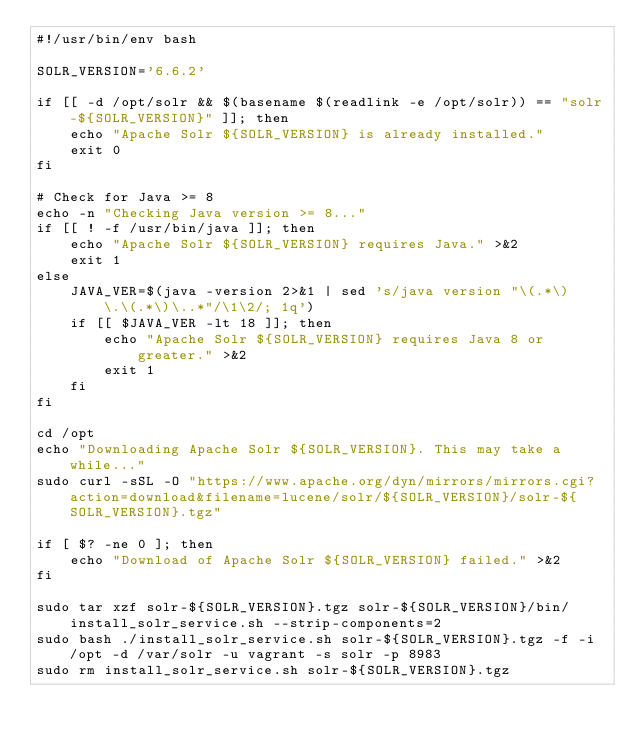<code> <loc_0><loc_0><loc_500><loc_500><_Bash_>#!/usr/bin/env bash

SOLR_VERSION='6.6.2'

if [[ -d /opt/solr && $(basename $(readlink -e /opt/solr)) == "solr-${SOLR_VERSION}" ]]; then
	echo "Apache Solr ${SOLR_VERSION} is already installed."
	exit 0
fi

# Check for Java >= 8
echo -n "Checking Java version >= 8..."
if [[ ! -f /usr/bin/java ]]; then
	echo "Apache Solr ${SOLR_VERSION} requires Java." >&2
	exit 1
else
	JAVA_VER=$(java -version 2>&1 | sed 's/java version "\(.*\)\.\(.*\)\..*"/\1\2/; 1q')
	if [[ $JAVA_VER -lt 18 ]]; then
		echo "Apache Solr ${SOLR_VERSION} requires Java 8 or greater." >&2
		exit 1
	fi
fi

cd /opt
echo "Downloading Apache Solr ${SOLR_VERSION}. This may take a while..."
sudo curl -sSL -O "https://www.apache.org/dyn/mirrors/mirrors.cgi?action=download&filename=lucene/solr/${SOLR_VERSION}/solr-${SOLR_VERSION}.tgz"

if [ $? -ne 0 ]; then
	echo "Download of Apache Solr ${SOLR_VERSION} failed." >&2
fi

sudo tar xzf solr-${SOLR_VERSION}.tgz solr-${SOLR_VERSION}/bin/install_solr_service.sh --strip-components=2
sudo bash ./install_solr_service.sh solr-${SOLR_VERSION}.tgz -f -i /opt -d /var/solr -u vagrant -s solr -p 8983
sudo rm install_solr_service.sh solr-${SOLR_VERSION}.tgz
</code> 